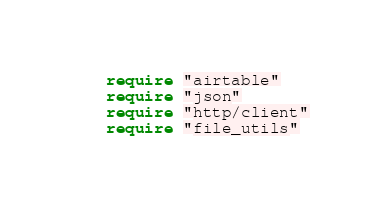Convert code to text. <code><loc_0><loc_0><loc_500><loc_500><_Crystal_>require "airtable"
require "json"
require "http/client"
require "file_utils"
</code> 